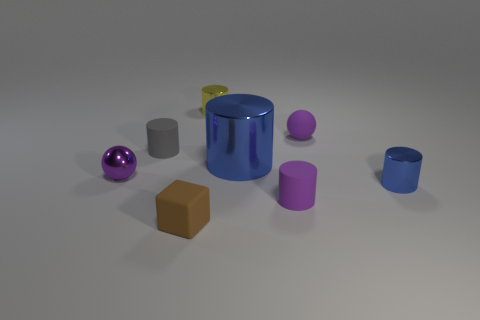What is the color of the other tiny metallic object that is the same shape as the tiny yellow thing?
Provide a short and direct response. Blue. What size is the yellow shiny thing?
Give a very brief answer. Small. How many cylinders are either brown metallic things or tiny purple metal things?
Your answer should be compact. 0. What is the size of the other rubber thing that is the same shape as the gray thing?
Offer a very short reply. Small. What number of small purple matte things are there?
Your response must be concise. 2. There is a big shiny object; is its shape the same as the tiny blue thing that is on the right side of the gray rubber thing?
Offer a very short reply. Yes. How big is the ball that is on the left side of the yellow shiny object?
Offer a very short reply. Small. What material is the small blue cylinder?
Offer a terse response. Metal. Do the metallic thing that is right of the small matte ball and the big object have the same shape?
Offer a very short reply. Yes. There is a metallic cylinder that is the same color as the big shiny thing; what is its size?
Make the answer very short. Small. 